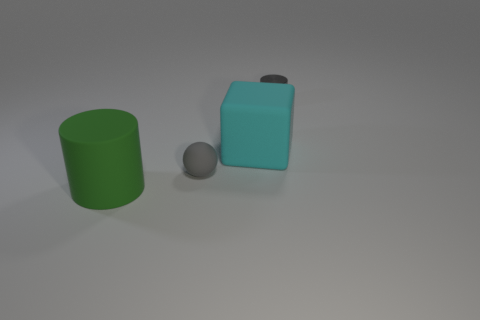Add 3 large cyan matte blocks. How many objects exist? 7 Subtract all blocks. How many objects are left? 3 Add 1 big brown metal cylinders. How many big brown metal cylinders exist? 1 Subtract 0 yellow spheres. How many objects are left? 4 Subtract all red metallic objects. Subtract all tiny cylinders. How many objects are left? 3 Add 2 small gray shiny things. How many small gray shiny things are left? 3 